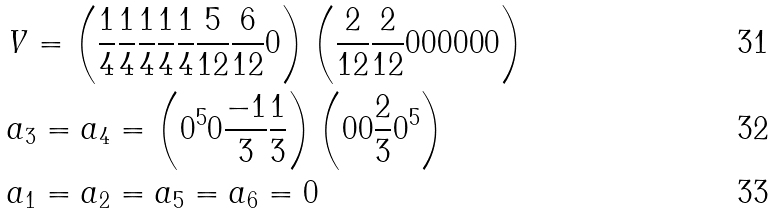<formula> <loc_0><loc_0><loc_500><loc_500>& V = \left ( \frac { 1 } { 4 } \frac { 1 } { 4 } \frac { 1 } { 4 } \frac { 1 } { 4 } \frac { 1 } { 4 } \frac { 5 } { 1 2 } \frac { 6 } { 1 2 } 0 \right ) \left ( \frac { 2 } { 1 2 } \frac { 2 } { 1 2 } 0 0 0 0 0 0 \right ) \\ & a _ { 3 } = a _ { 4 } = \left ( 0 ^ { 5 } 0 \frac { - 1 } { 3 } \frac { 1 } { 3 } \right ) \left ( 0 0 \frac { 2 } { 3 } 0 ^ { 5 } \right ) \\ & a _ { 1 } = a _ { 2 } = a _ { 5 } = a _ { 6 } = 0</formula> 